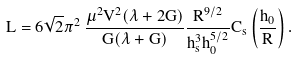Convert formula to latex. <formula><loc_0><loc_0><loc_500><loc_500>L = 6 \sqrt { 2 } \pi ^ { 2 } \, \frac { \mu ^ { 2 } V ^ { 2 } ( \lambda + 2 G ) } { G ( \lambda + G ) } \frac { R ^ { 9 / 2 } } { h _ { s } ^ { 3 } h _ { 0 } ^ { 5 / 2 } } C _ { s } \left ( \frac { h _ { 0 } } { R } \right ) .</formula> 